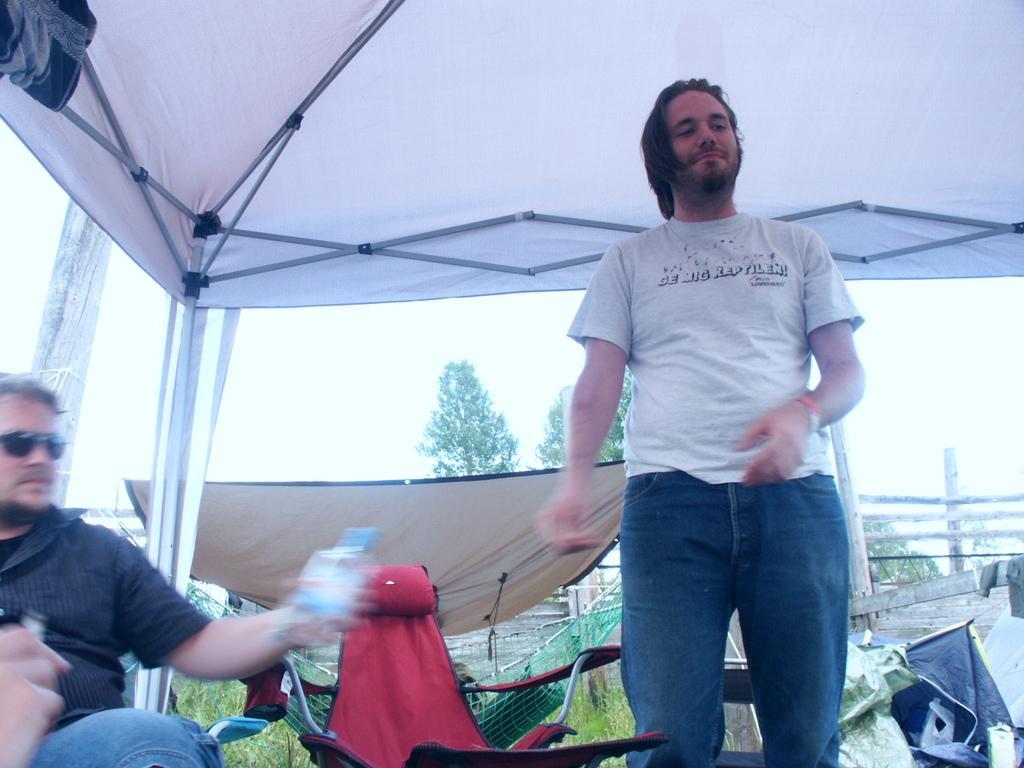Can you describe this image briefly? In this image there is the sky, there are trees, there are tents, there is a tent towards the top of the image, there is a man standing, there is a man sitting and holding a water bottle, there is a hammock, there is a person in the hammock, there is a chair, there are objects towards the bottom of the image, there is an wooden fencing towards the right of the image, there is grass. 